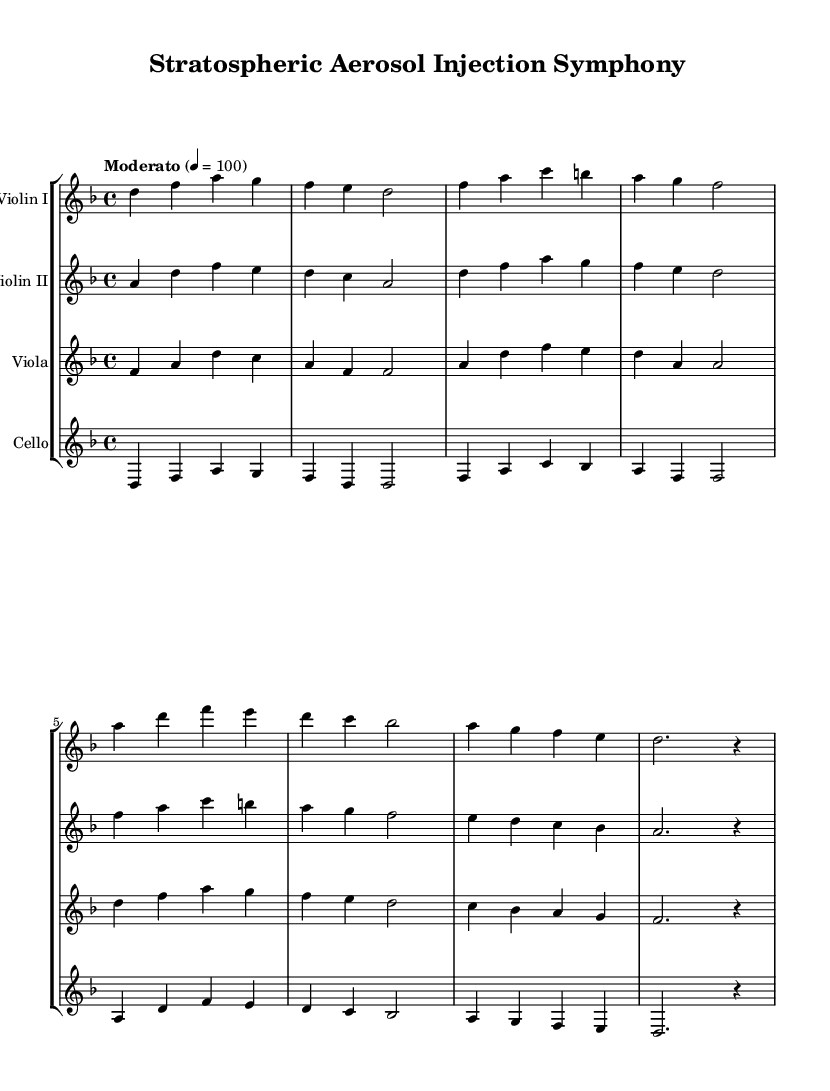What is the key signature of this music? The key signature is indicated at the beginning of the score as one flat, which is characteristic of D minor.
Answer: D minor What is the time signature of this music? The time signature, appearing at the beginning of the score, shows that there are four beats in each measure.
Answer: 4/4 What tempo marking is used in this score? The tempo marking, found above the staff, indicates a moderate speed at a specific beats-per-minute rate. The marking states "Moderato" and gives a tempo of quarter note = 100.
Answer: Moderato Which instruments are featured in this composition? The score includes four distinct staves labeled with the respective instruments, clearly marking the ensemble involved in the piece.
Answer: Violin I, Violin II, Viola, Cello What is the rhythmic structure of the introduction? The introduction features a pattern of quarter notes and half notes. By observing the first measures, we can see that it alternates between these note values across all instruments.
Answer: Alternating quarter notes and half notes How does the melody evolve in Theme A? In Theme A, the melodic line can be traced from the introduction, with distinct intervals and phrases that span multiple measures, noting the shifts in notes to establish a thematic continuity. The violins start the theme while the viola and cello provide harmonic support.
Answer: The melody gradually descends and ascends using intervals of thirds and fourths What is the closing rhythm of the Theme A section? The final measures of Theme A show a specific rhythmic pattern summed up by the last notes which indicate a pause or a rest instead of a continuation. The rhythms can be analyzed by looking closely at the last note values given at the end of the phrase.
Answer: A half note followed by a rest 